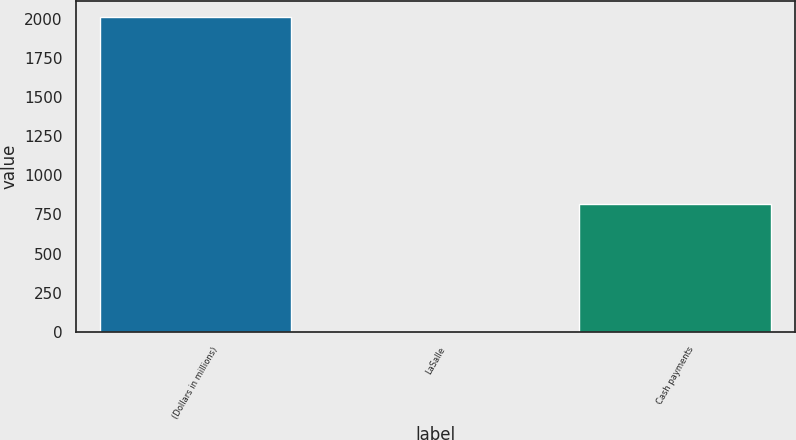<chart> <loc_0><loc_0><loc_500><loc_500><bar_chart><fcel>(Dollars in millions)<fcel>LaSalle<fcel>Cash payments<nl><fcel>2009<fcel>6<fcel>816<nl></chart> 